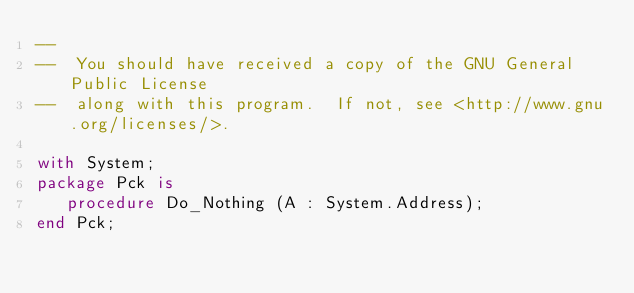Convert code to text. <code><loc_0><loc_0><loc_500><loc_500><_Ada_>--
--  You should have received a copy of the GNU General Public License
--  along with this program.  If not, see <http://www.gnu.org/licenses/>.

with System;
package Pck is
   procedure Do_Nothing (A : System.Address);
end Pck;
</code> 